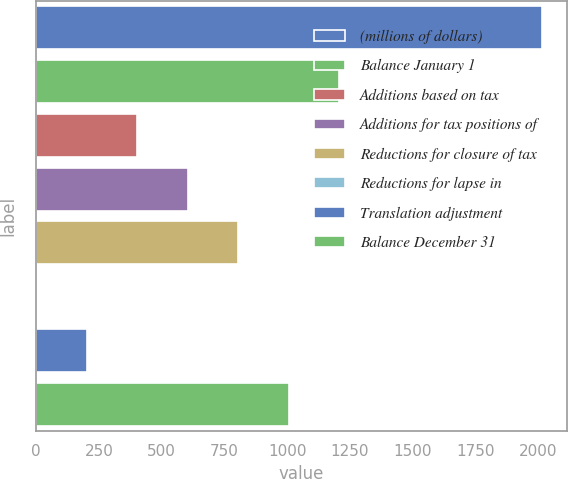<chart> <loc_0><loc_0><loc_500><loc_500><bar_chart><fcel>(millions of dollars)<fcel>Balance January 1<fcel>Additions based on tax<fcel>Additions for tax positions of<fcel>Reductions for closure of tax<fcel>Reductions for lapse in<fcel>Translation adjustment<fcel>Balance December 31<nl><fcel>2013<fcel>1207.88<fcel>402.76<fcel>604.04<fcel>805.32<fcel>0.2<fcel>201.48<fcel>1006.6<nl></chart> 